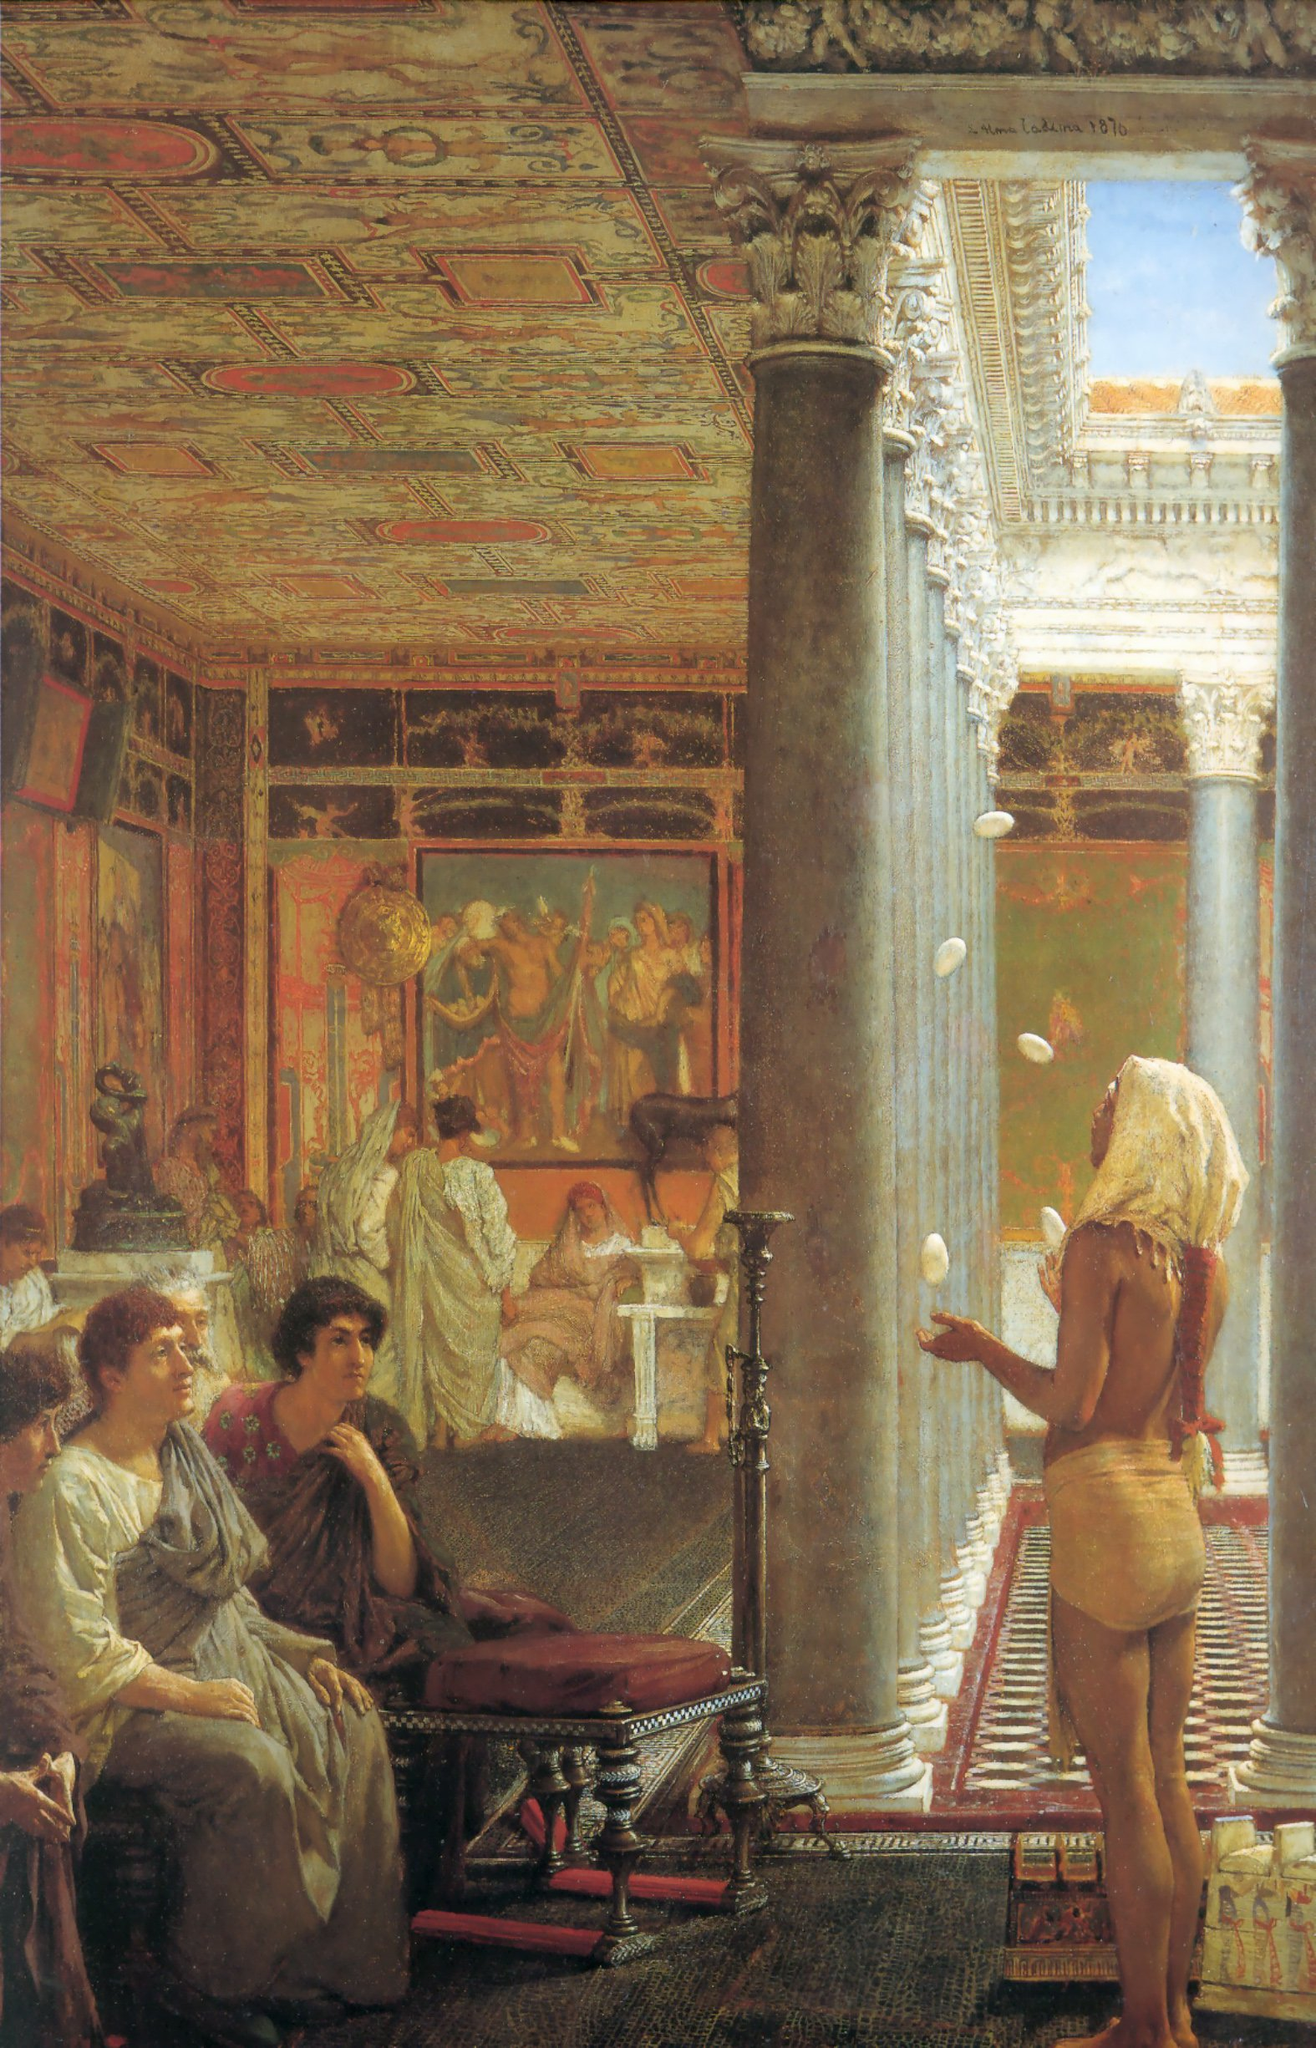Given the luxurious setting, who might be the owner of this room and what could their story be? The owner of this magnificent room could be a wealthy and influential patrician, perhaps a senator or a renowned general of the Roman Empire. His name is Lucius Marcellus, known for his strategic brilliance in battles that expanded the empire's borders. After retiring from the military, Marcellus devoted his wealth to the patronage of arts and philosophy. This room, part of his vast estate, serves as a salon where intellectuals, artists, and dignitaries gather to discuss and celebrate their works. Marcellus' story is one of valor on the battlefield transforming into a legacy of cultural and intellectual enrichment, his home a testament to his appreciation for the profound and the beautiful. 